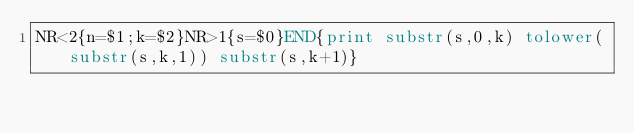Convert code to text. <code><loc_0><loc_0><loc_500><loc_500><_Awk_>NR<2{n=$1;k=$2}NR>1{s=$0}END{print substr(s,0,k) tolower(substr(s,k,1)) substr(s,k+1)}</code> 